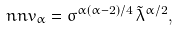Convert formula to latex. <formula><loc_0><loc_0><loc_500><loc_500>\ n n v _ { \alpha } = \sigma ^ { \alpha ( \alpha - 2 ) / 4 } \, \tilde { \lambda } ^ { \alpha / 2 } ,</formula> 